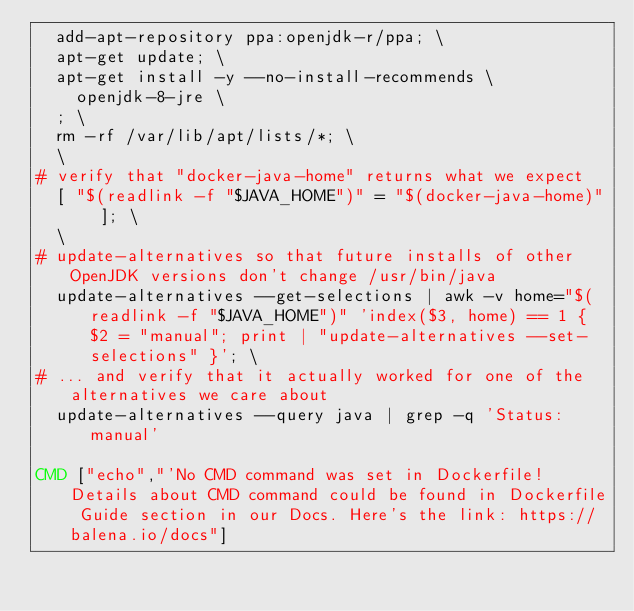<code> <loc_0><loc_0><loc_500><loc_500><_Dockerfile_>	add-apt-repository ppa:openjdk-r/ppa; \
	apt-get update; \
	apt-get install -y --no-install-recommends \
		openjdk-8-jre \
	; \
	rm -rf /var/lib/apt/lists/*; \
	\
# verify that "docker-java-home" returns what we expect
	[ "$(readlink -f "$JAVA_HOME")" = "$(docker-java-home)" ]; \
	\
# update-alternatives so that future installs of other OpenJDK versions don't change /usr/bin/java
	update-alternatives --get-selections | awk -v home="$(readlink -f "$JAVA_HOME")" 'index($3, home) == 1 { $2 = "manual"; print | "update-alternatives --set-selections" }'; \
# ... and verify that it actually worked for one of the alternatives we care about
	update-alternatives --query java | grep -q 'Status: manual'

CMD ["echo","'No CMD command was set in Dockerfile! Details about CMD command could be found in Dockerfile Guide section in our Docs. Here's the link: https://balena.io/docs"]
</code> 